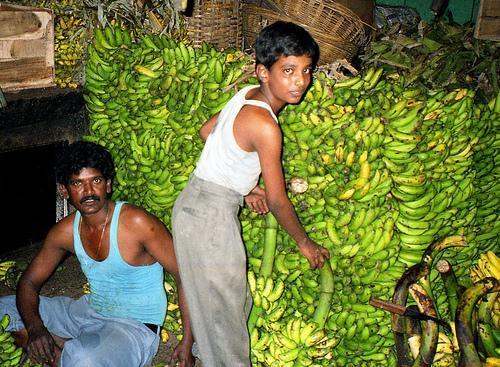How many people are visible?
Give a very brief answer. 2. 